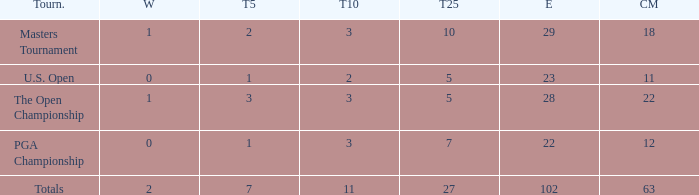How many vuts made for a player with 2 wins and under 7 top 5s? None. 